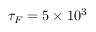Convert formula to latex. <formula><loc_0><loc_0><loc_500><loc_500>\tau _ { F } = 5 \times 1 0 ^ { 3 }</formula> 